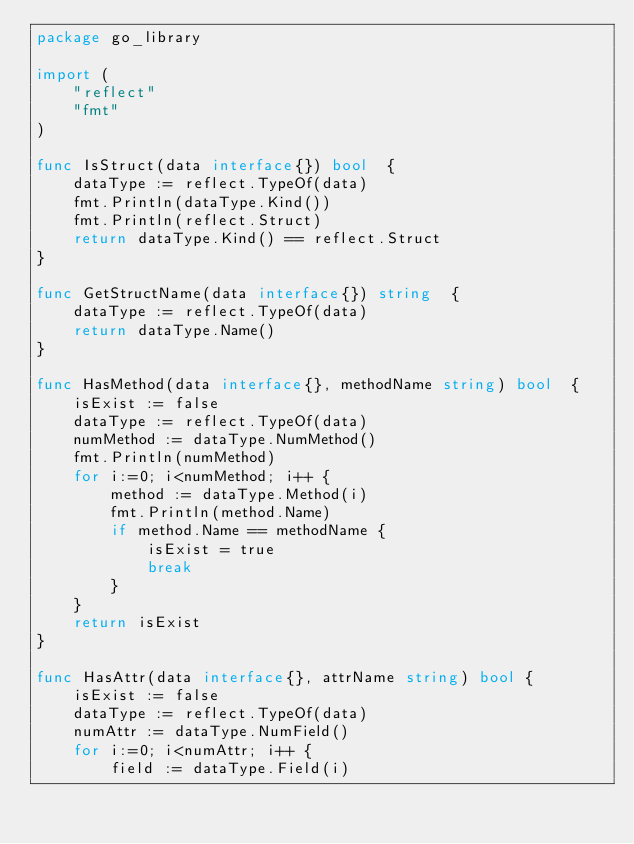<code> <loc_0><loc_0><loc_500><loc_500><_Go_>package go_library

import (
	"reflect"
	"fmt"
)

func IsStruct(data interface{}) bool  {
	dataType := reflect.TypeOf(data)
	fmt.Println(dataType.Kind())
	fmt.Println(reflect.Struct)
	return dataType.Kind() == reflect.Struct
}

func GetStructName(data interface{}) string  {
	dataType := reflect.TypeOf(data)
	return dataType.Name()
}

func HasMethod(data interface{}, methodName string) bool  {
	isExist := false
	dataType := reflect.TypeOf(data)
	numMethod := dataType.NumMethod()
	fmt.Println(numMethod)
	for i:=0; i<numMethod; i++ {
		method := dataType.Method(i)
		fmt.Println(method.Name)
		if method.Name == methodName {
			isExist = true
			break
		}
	}
	return isExist
}

func HasAttr(data interface{}, attrName string) bool {
	isExist := false
	dataType := reflect.TypeOf(data)
	numAttr := dataType.NumField()
	for i:=0; i<numAttr; i++ {
		field := dataType.Field(i)</code> 